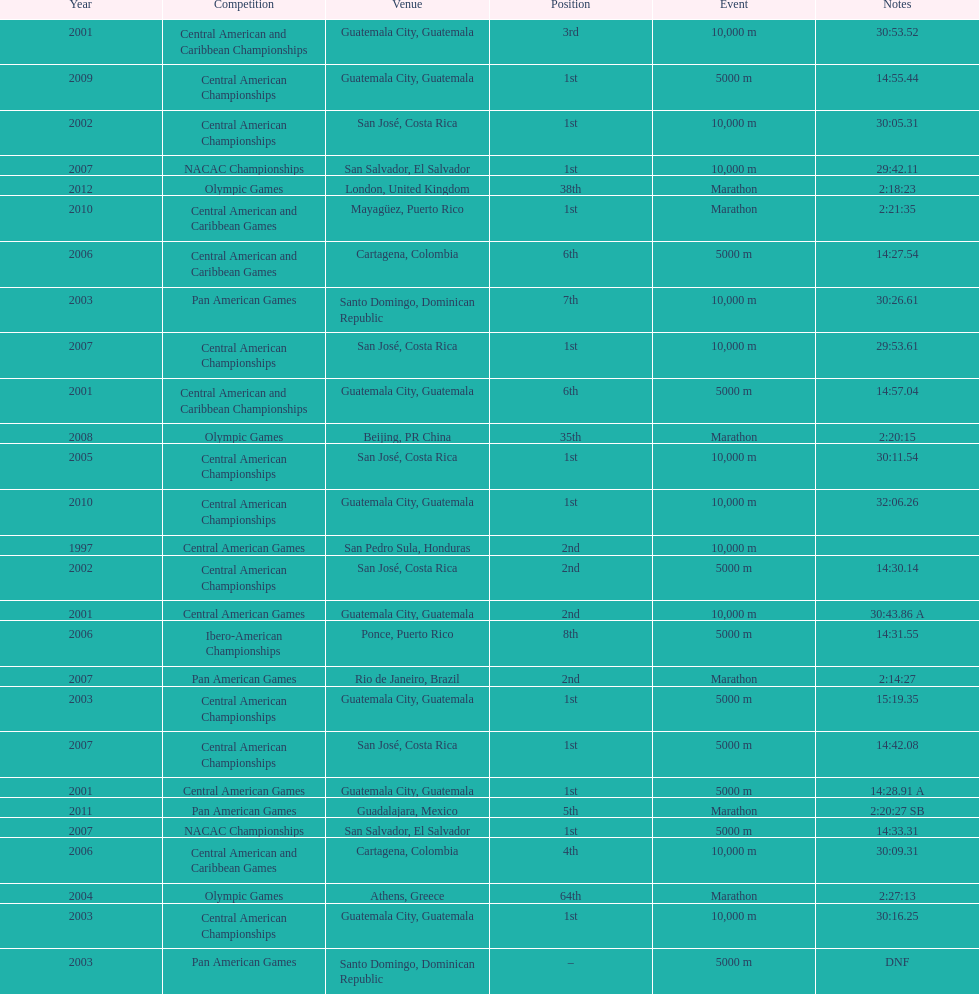The central american championships and what other competition occurred in 2010? Central American and Caribbean Games. 